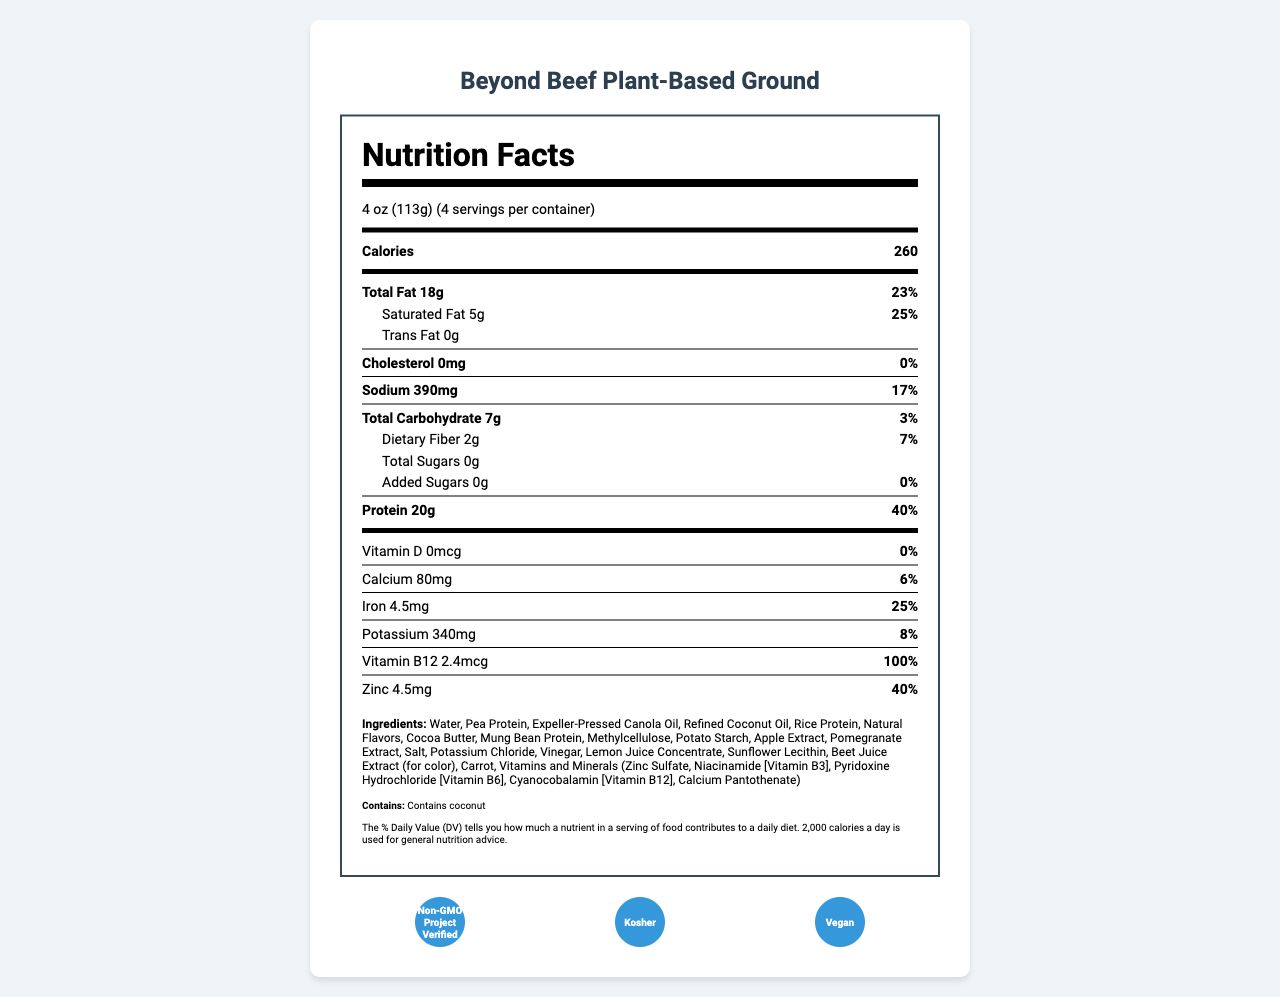what is the serving size of the product? The serving size listed on the label is 4 oz (113g).
Answer: 4 oz (113g) how many calories are there per serving? The label indicates that there are 260 calories per serving.
Answer: 260 how much protein is in one serving? According to the document, one serving contains 20g of protein.
Answer: 20g what percentage of Daily Value (DV) is the protein content per serving? The percentage of Daily Value for protein per serving is shown as 40%.
Answer: 40% what vitamins and minerals are included in the product? The product includes Vitamin D, Calcium, Iron, Potassium, Vitamin B12, and Zinc as listed on the label.
Answer: Vitamin D, Calcium, Iron, Potassium, Vitamin B12, Zinc which ingredient is added for color? A. Beet Juice Extract B. Turmeric C. Paprika D. Spirulina The document lists Beet Juice Extract (for color) among the ingredients.
Answer: A what is the total fat content per serving and its percentage of the Daily Value? The total fat content per serving is 18g, and it accounts for 23% of the Daily Value.
Answer: 18g, 23% which allergen is mentioned in the document? A. Soy B. Wheat C. Coconut D. Dairy The document lists coconut as the allergen contained in the product.
Answer: C is the product suitable for a vegan diet? The product is labeled as "Vegan" under certifications.
Answer: Yes how many servings are there per container? The serving information indicates that there are 4 servings per container.
Answer: 4 how much sodium is in one serving? The sodium content per serving is listed as 390mg.
Answer: 390mg does the product contain any cholesterol? The document specifies that the cholesterol amount is 0mg, indicating that the product contains no cholesterol.
Answer: No what certifications does the product have? The listed certifications include Non-GMO Project Verified, Kosher, and Vegan.
Answer: Non-GMO Project Verified, Kosher, Vegan what is the legal disclaimer about the Daily Value percentages? The legal disclaimer states that the % Daily Value tells how much a nutrient in a serving contributes to a daily diet, based on a 2,000 calorie daily intake.
Answer: The % Daily Value (DV) tells you how much a nutrient in a serving of food contributes to a daily diet. 2,000 calories a day is used for general nutrition advice. which regulatory acts does this label comply with? The label complies with FDA Regulation 21 CFR 101.9 and the Nutrition Labeling and Education Act of 1990.
Answer: 21 CFR 101.9, Nutrition Labeling and Education Act of 1990 was there any recent update to the Nutrition Facts label regulations? The document mentions that the label was updated to comply with the FDA's 2016 Nutrition Facts label regulations, effective January 1, 2020, for manufacturers with $10 million or more in annual food sales.
Answer: Yes what is the main idea of the document? The document summarizes the nutrients, ingredients, and other relevant information needed to understand the nutritional profile of the Beyond Beef Plant-Based Ground product.
Answer: The document provides detailed nutritional information for the Beyond Beef Plant-Based Ground, including its serving size, calorie count, macronutrient contents (fats, carbohydrates, protein), vitamins, minerals, ingredients, allergens, certifications, legal disclaimers, and regulatory context. is there information about where the product is manufactured? Based on the visual information available, the document does not specify the manufacturing location details. Only the manufacturer's name, address, and website are given.
Answer: Not enough information 